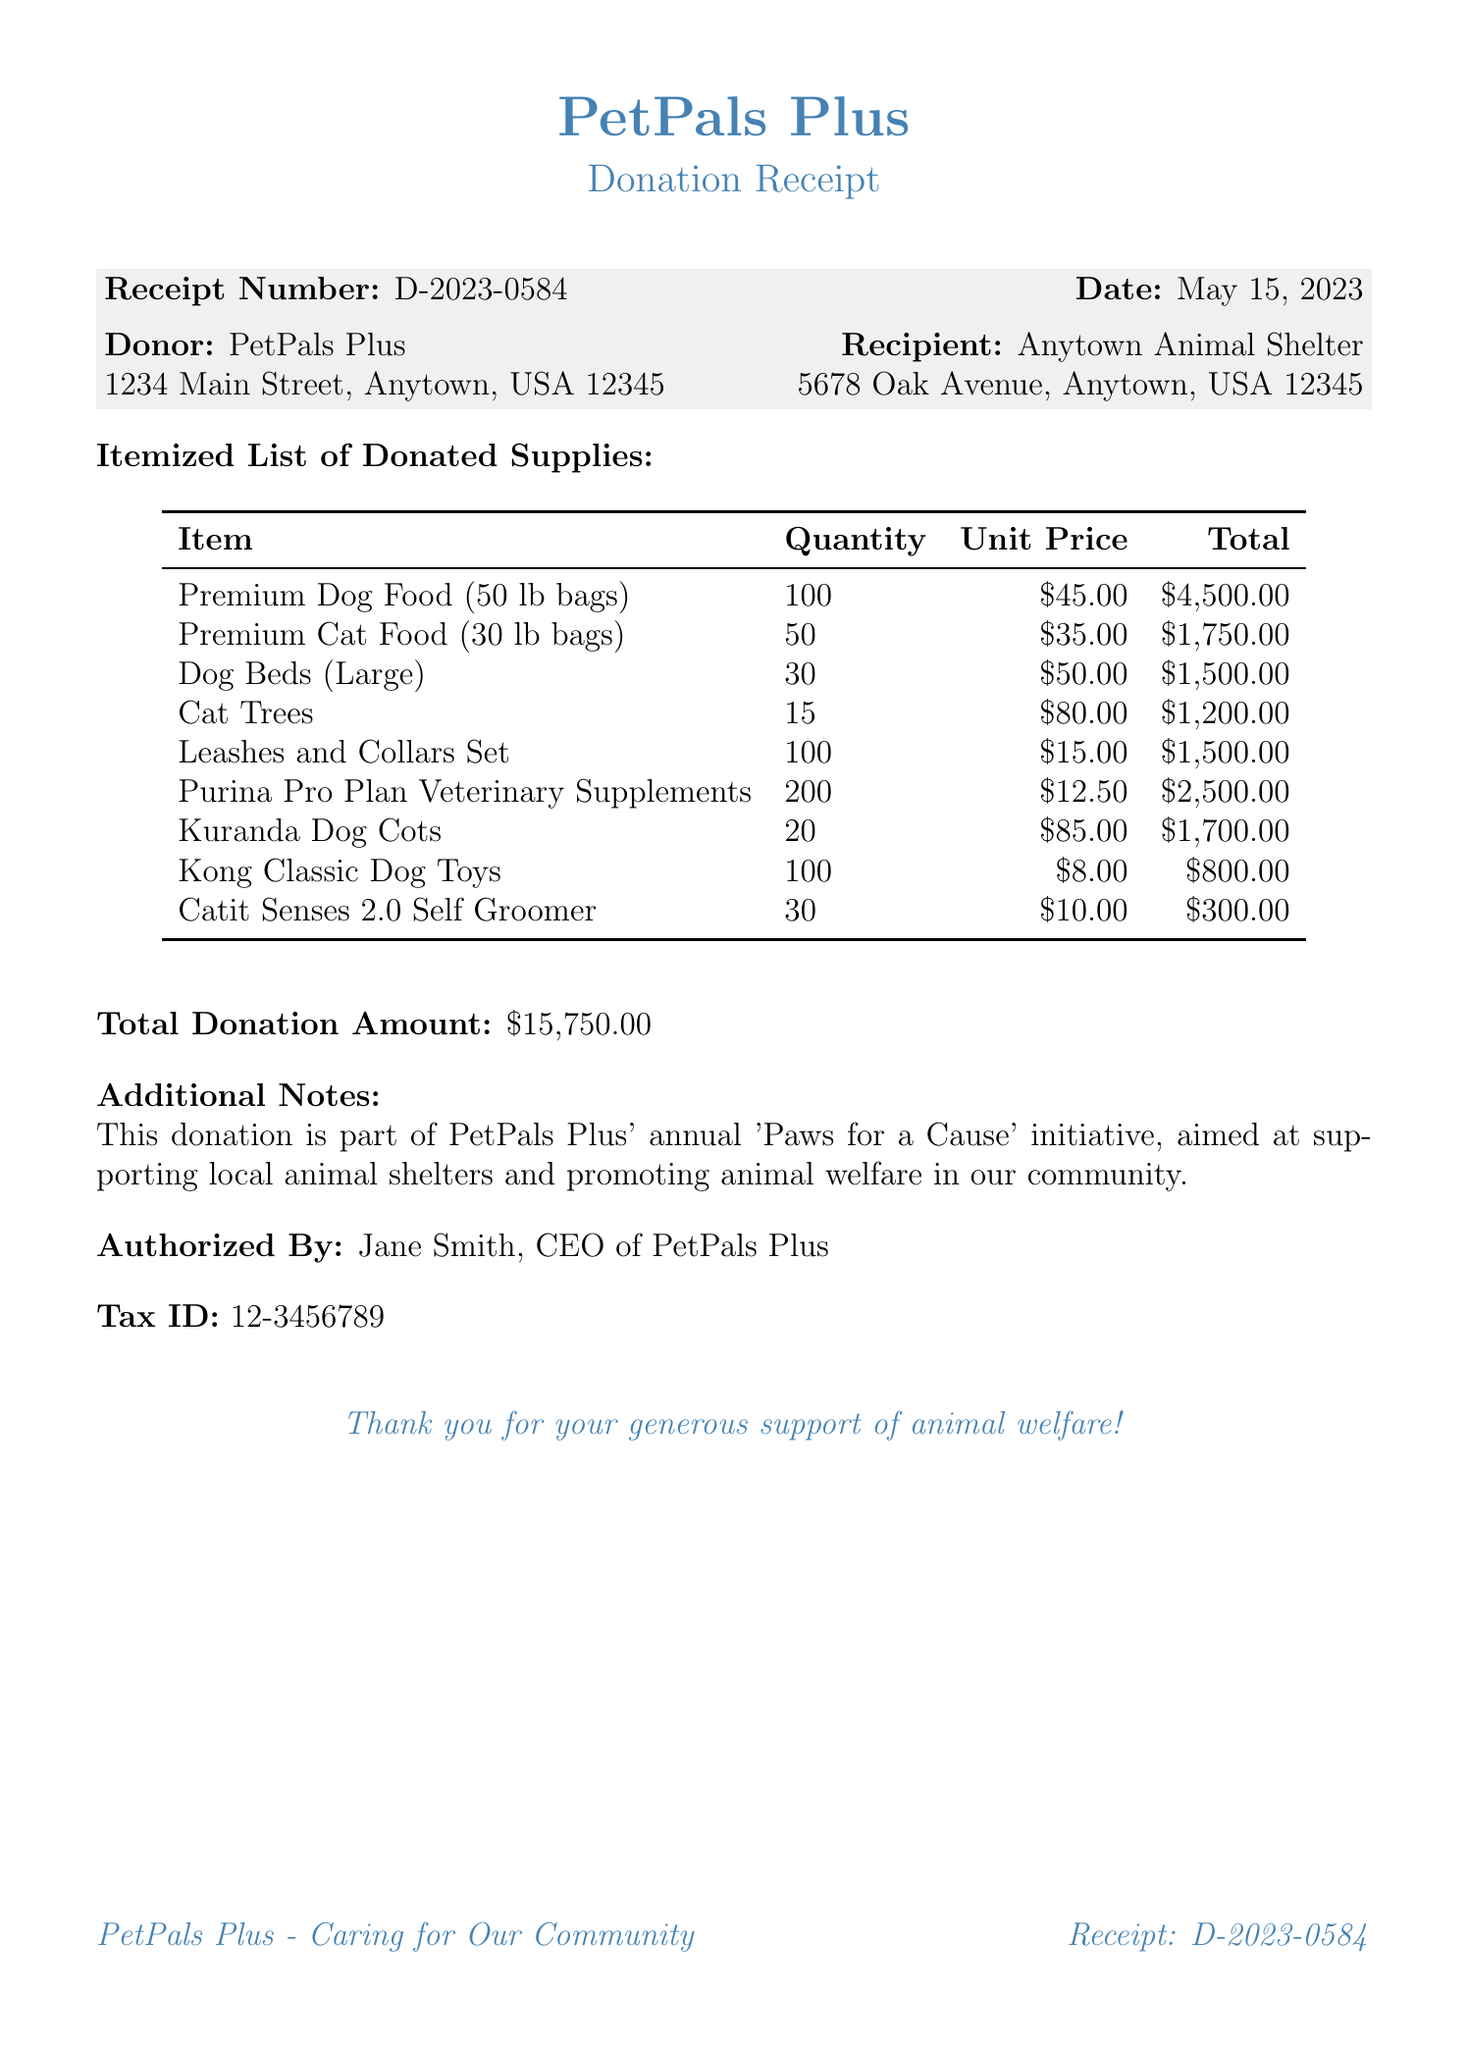Who is the authorized signer of the donation? The authorized signer is the individual who confirms and validates the donation, here named as Jane Smith, the CEO of PetPals Plus.
Answer: Jane Smith How many Premium Dog Food bags were donated? The quantity of Premium Dog Food bags donated is specified in the itemized list, which states 100 bags.
Answer: 100 What initiative is this donation part of? The donation's purpose is linked to a specific initiative that aims to help local animal shelters, named 'Paws for a Cause.'
Answer: Paws for a Cause What is the unit price of the Cat Trees? The unit price is the individual cost of each item in the donation, which for Cat Trees is reported as $80.00.
Answer: $80.00 How many total items were listed in the donation? To find the total items, you can count from the list of different types of supplies itemized, which sums to 9 unique items.
Answer: 9 What is the address of the recipient shelter? The address provided for the recipient, Anytown Animal Shelter, is necessary to identify where the donation is going, detailed as 5678 Oak Avenue, Anytown, USA 12345.
Answer: 5678 Oak Avenue, Anytown, USA 12345 What is the tax ID of PetPals Plus? This number is relevant for documentation and tax purposes, presented in the receipt as 12-3456789.
Answer: 12-3456789 